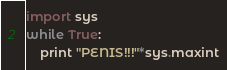Convert code to text. <code><loc_0><loc_0><loc_500><loc_500><_Python_>import sys
while True:
    print "PENIS!!!"*sys.maxint</code> 